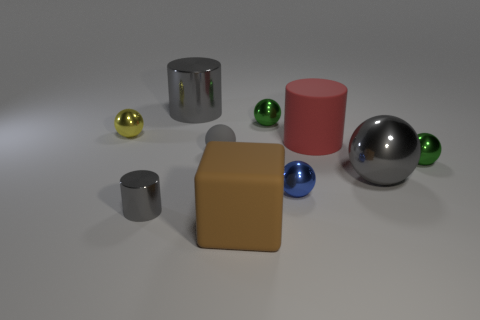Subtract all big shiny spheres. How many spheres are left? 5 Subtract all yellow spheres. How many spheres are left? 5 Subtract all yellow spheres. Subtract all yellow cylinders. How many spheres are left? 5 Subtract all spheres. How many objects are left? 4 Add 5 tiny yellow shiny objects. How many tiny yellow shiny objects are left? 6 Add 5 small gray shiny cylinders. How many small gray shiny cylinders exist? 6 Subtract 0 brown cylinders. How many objects are left? 10 Subtract all tiny metallic balls. Subtract all big gray balls. How many objects are left? 5 